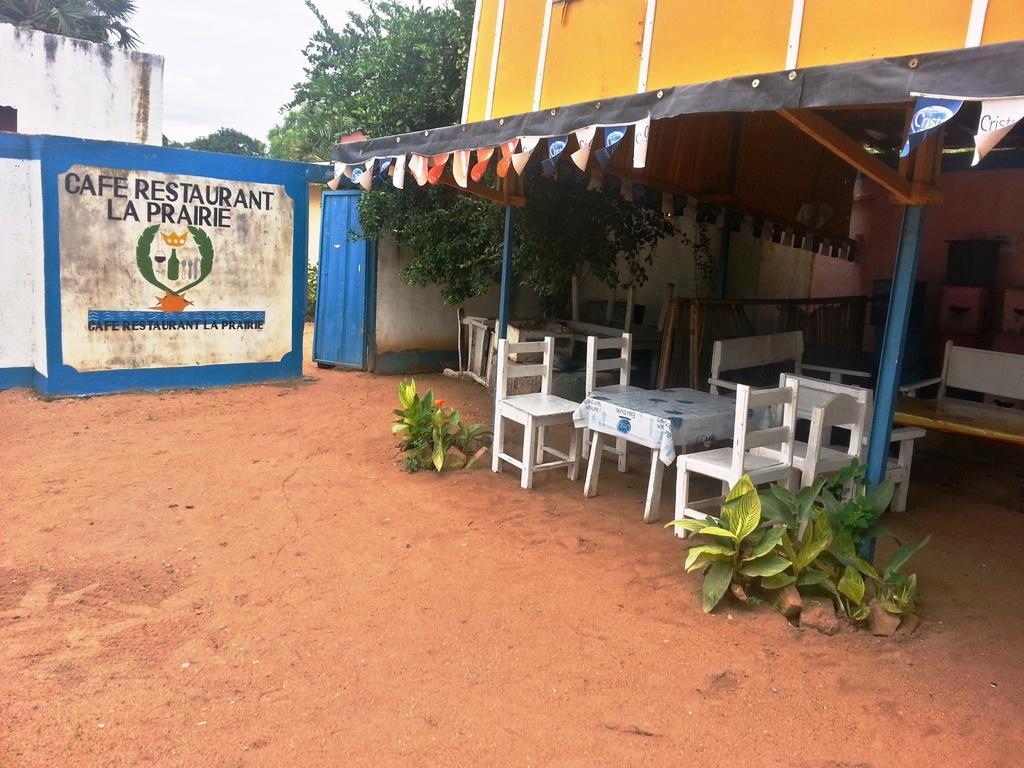Describe this image in one or two sentences. In the center of the image we can see the sky, clouds, trees, buildings, banners, tables, chairs, one cloth, plants, compound wall and a few other objects. And we can see some text on the wall. 